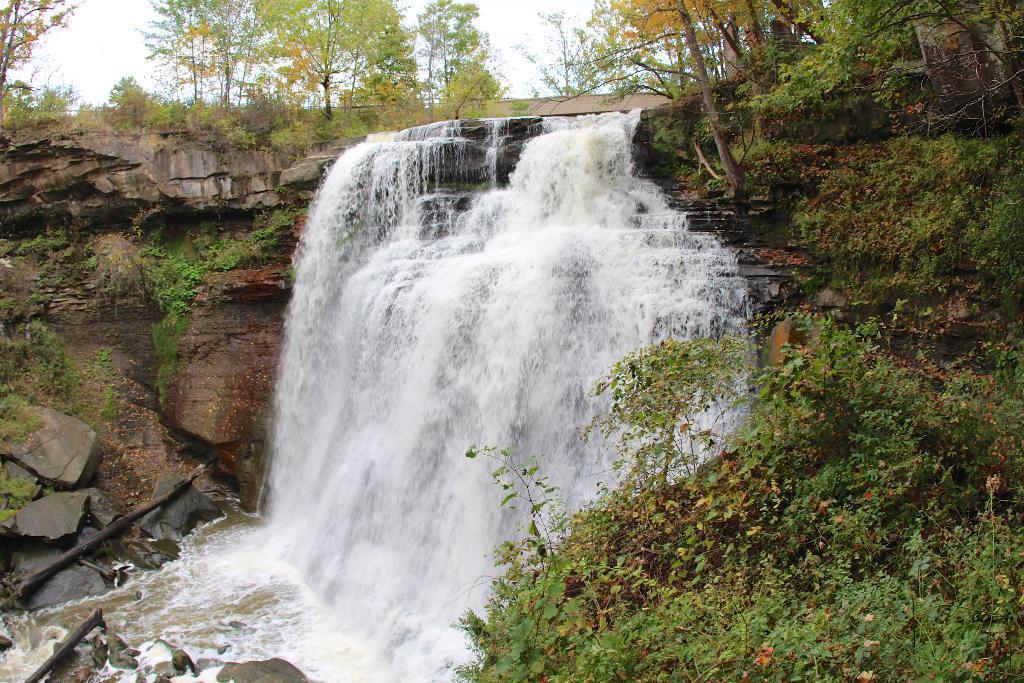Describe this image in one or two sentences. In this image we can see the waterfalls. We can also see the grass, rocks, plants and also trees. Sky is also visible. 